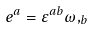Convert formula to latex. <formula><loc_0><loc_0><loc_500><loc_500>e ^ { a } = \varepsilon ^ { a b } \omega , _ { b }</formula> 